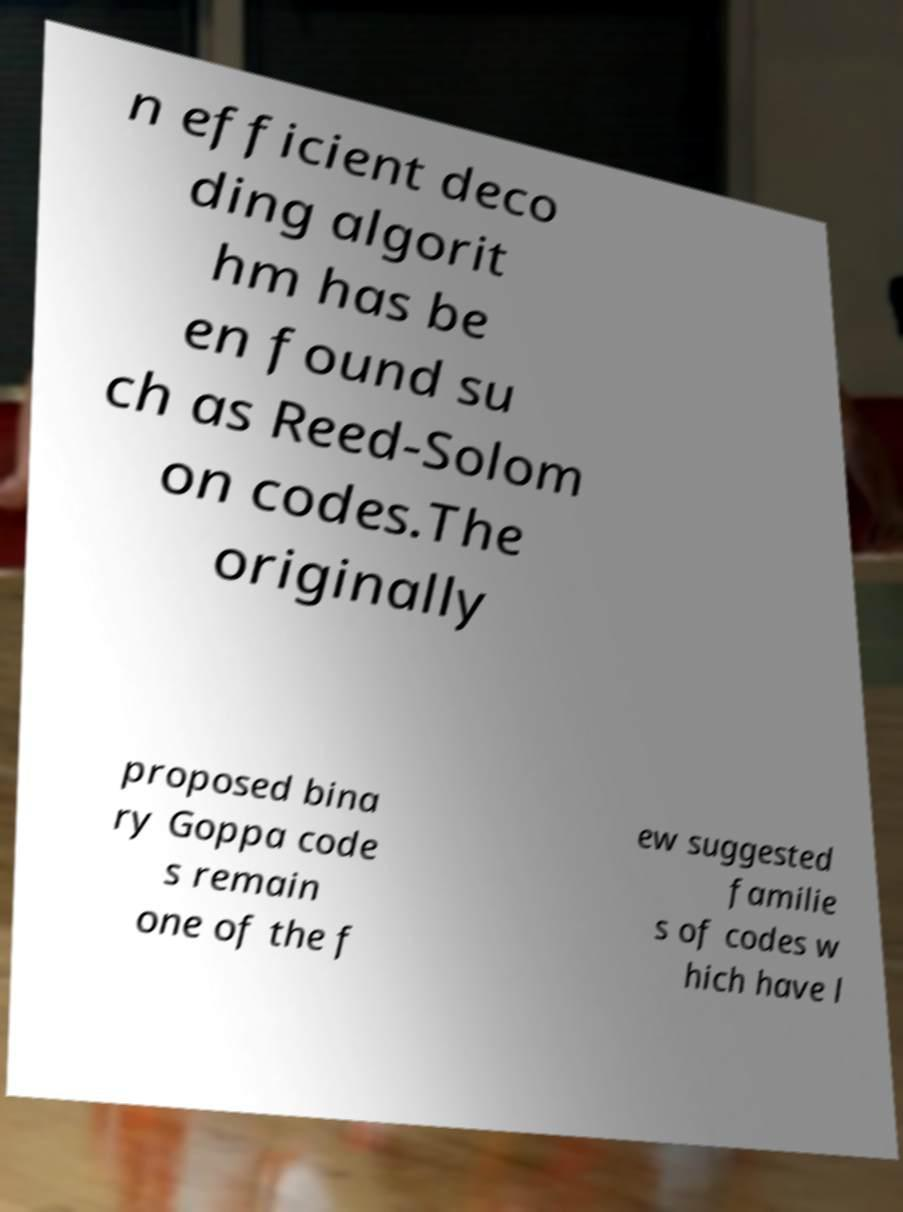Could you extract and type out the text from this image? n efficient deco ding algorit hm has be en found su ch as Reed-Solom on codes.The originally proposed bina ry Goppa code s remain one of the f ew suggested familie s of codes w hich have l 